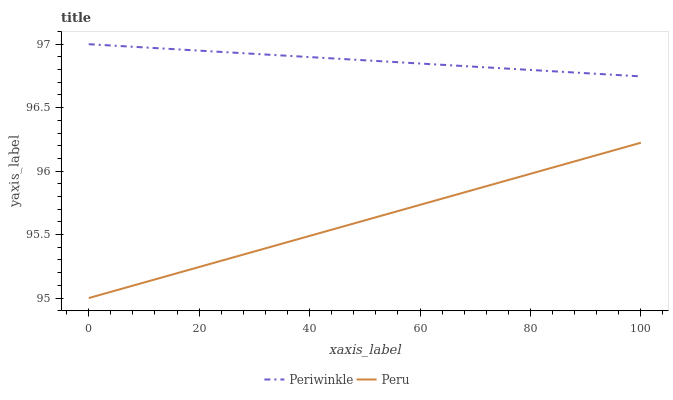Does Peru have the minimum area under the curve?
Answer yes or no. Yes. Does Periwinkle have the maximum area under the curve?
Answer yes or no. Yes. Does Peru have the maximum area under the curve?
Answer yes or no. No. Is Periwinkle the smoothest?
Answer yes or no. Yes. Is Peru the roughest?
Answer yes or no. Yes. Is Peru the smoothest?
Answer yes or no. No. Does Peru have the lowest value?
Answer yes or no. Yes. Does Periwinkle have the highest value?
Answer yes or no. Yes. Does Peru have the highest value?
Answer yes or no. No. Is Peru less than Periwinkle?
Answer yes or no. Yes. Is Periwinkle greater than Peru?
Answer yes or no. Yes. Does Peru intersect Periwinkle?
Answer yes or no. No. 